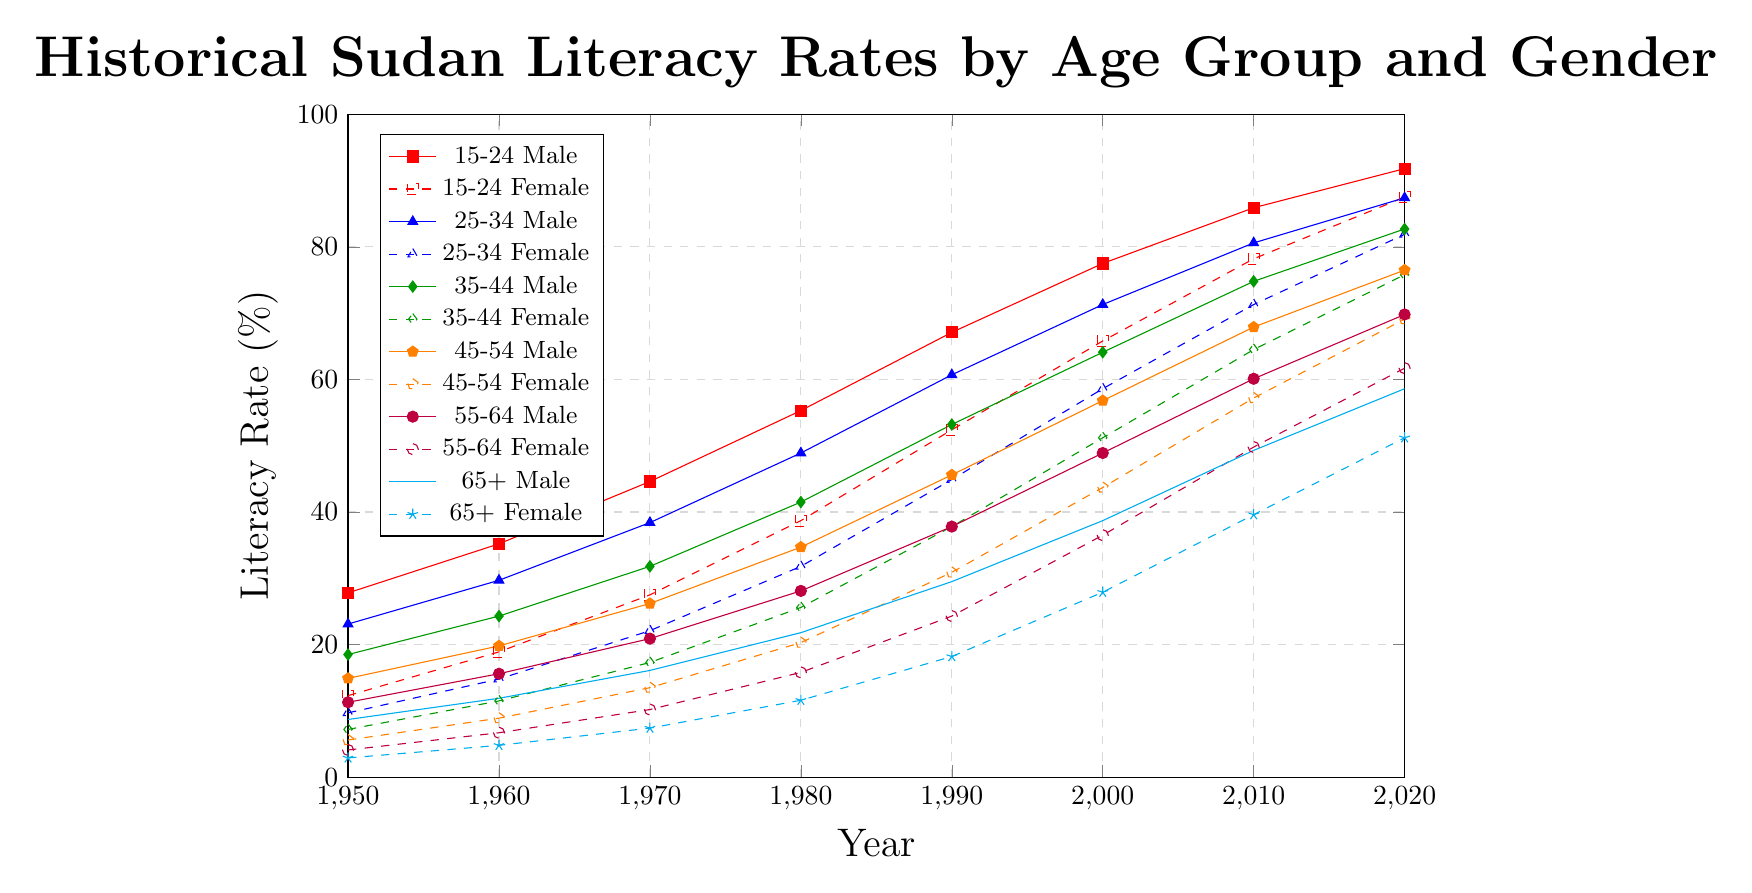How does the literacy rate for 15-24 females change from 1950 to 2020? First, see the rate for 15-24 females in 1950 (12.3%) and 2020 (87.5%). The change is 87.5% - 12.3% = 75.2%.
Answer: 75.2% Which age group of females had the highest increase in literacy rate from 1950 to 2020? Compare the increases for each female age group: 15-24: 87.5% - 12.3% = 75.2%, 25-34: 81.9% - 9.7% = 72.2%, 35-44: 75.8% - 7.2% = 68.6%, 45-54: 69.1% - 5.6% = 63.5%, 55-64: 61.7% - 4.1% = 57.6%, 65+: 51.2% - 2.9% = 48.3%. The highest increase is for 15-24 females.
Answer: 15-24 In which year did the literacy rate for 35-44 males surpass 50%? Look at the data for 35-44 males: 1950: 18.5%, 1960: 24.3%, 1970: 31.8%, 1980: 41.5%, 1990: 53.2%. The rate surpasses 50% in 1990.
Answer: 1990 Compare the literacy rates of 45-54 males and females in 1960. Which gender had a higher rate? For 1960, check literacy rates for 45-54 males (19.8%) and females (8.9%). Males had a higher rate.
Answer: Males By how much did the literacy rate for 65+ males increase from 1950 to 2000? For 65+ males, 1950 rate is 8.7%, and 2000 rate is 38.7%. The increase is 38.7% - 8.7% = 30%.
Answer: 30% Which age group showed the smallest difference in literacy rate between males and females in 2020? Compare the differences in 2020: 15-24: 91.8% - 87.5% = 4.3%, 25-34: 87.4% - 81.9% = 5.5%, 35-44: 82.7% - 75.8% = 6.9%, 45-54: 76.5% - 69.1% = 7.4%, 55-64: 69.8% - 61.7% = 8.1%, 65+: 58.6% - 51.2% = 7.4%. The smallest difference is for the 15-24 group.
Answer: 15-24 What was the average literacy rate for 25-34 females across all recorded years? Add the rates for 25-34 females: 9.7% + 14.8% + 22.1% + 31.8% + 44.9% + 58.6% + 71.3% + 81.9% = 335.1%. There are 8 years, so the average is 335.1% / 8 = 41.89%.
Answer: 41.89% Which age group had the lowest literacy rate in 1950? Check 1950 rates: 15-24 M (27.8%), 15-24 F (12.3%), 25-34 M (23.1%), 25-34 F (9.7%), 35-44 M (18.5%), 35-44 F (7.2%), 45-54 M (14.9%), 45-54 F (5.6%), 55-64 M (11.3%), 55-64 F (4.1%), 65+ M (8.7%), 65+ F (2.9%). The lowest is for 65+ females.
Answer: 65+ females 